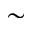<formula> <loc_0><loc_0><loc_500><loc_500>\sim</formula> 